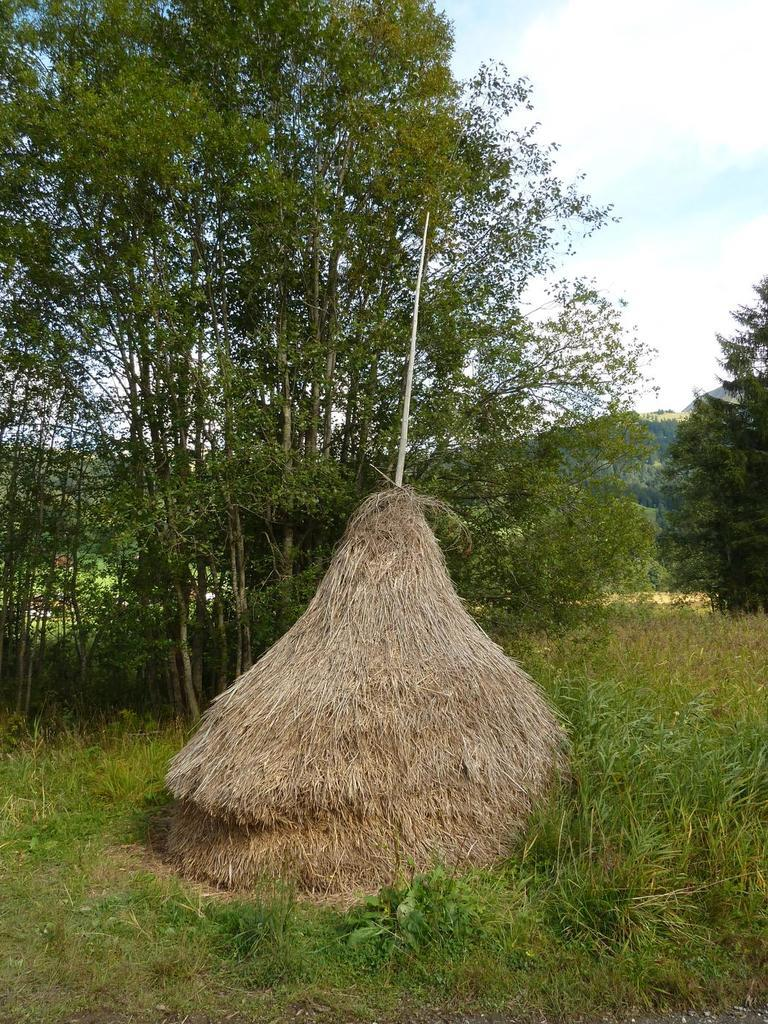What type of surface is visible in the image? There is a grass surface in the image. What type of plants are present on the grass surface? Grass plants are present on the grass surface. What type of structure is visible on the grass surface? There is a dried grass hut in the image. What feature can be seen on the dried grass hut? The dried grass hut has a pole on it. What can be seen in the background of the image? Trees and the sky are visible in the background of the image. What is present in the sky? Clouds are present in the sky. What type of collar can be seen on the frog in the image? There is no frog present in the image, so there is no collar to be seen. 